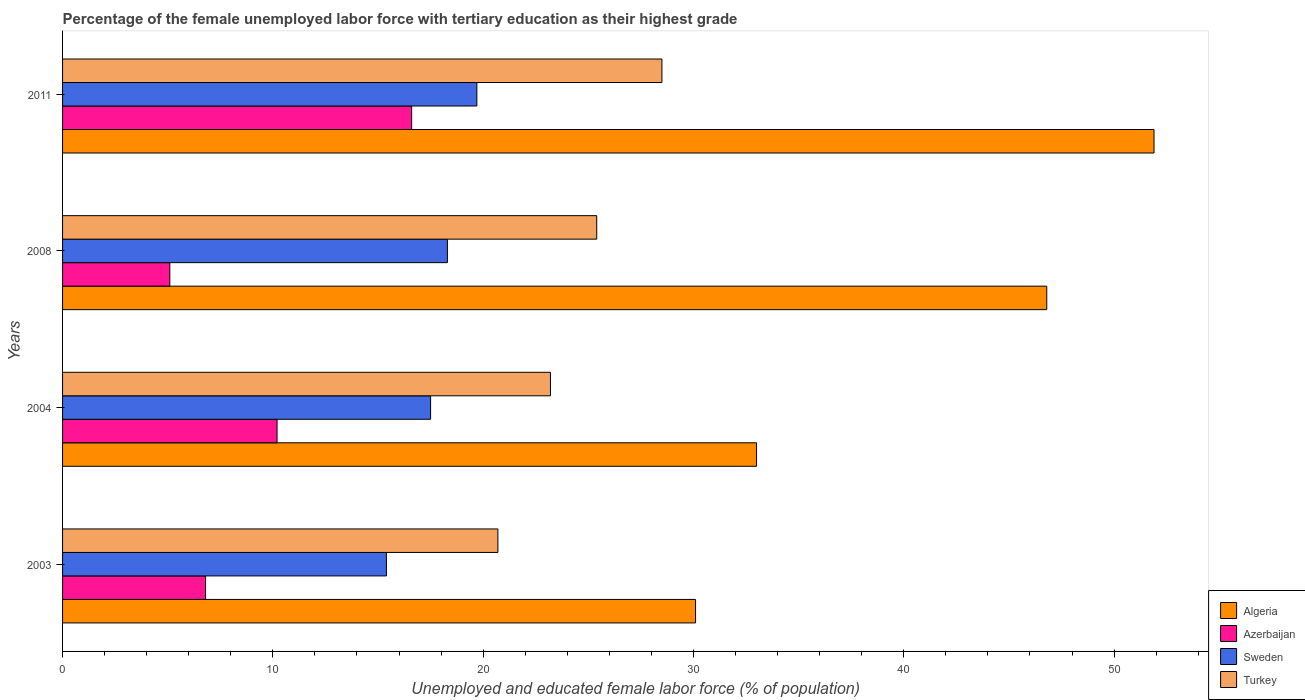How many different coloured bars are there?
Give a very brief answer. 4. How many groups of bars are there?
Your response must be concise. 4. Are the number of bars per tick equal to the number of legend labels?
Offer a very short reply. Yes. Are the number of bars on each tick of the Y-axis equal?
Give a very brief answer. Yes. How many bars are there on the 4th tick from the top?
Keep it short and to the point. 4. How many bars are there on the 3rd tick from the bottom?
Offer a very short reply. 4. What is the percentage of the unemployed female labor force with tertiary education in Sweden in 2008?
Give a very brief answer. 18.3. Across all years, what is the minimum percentage of the unemployed female labor force with tertiary education in Algeria?
Your answer should be compact. 30.1. What is the total percentage of the unemployed female labor force with tertiary education in Sweden in the graph?
Make the answer very short. 70.9. What is the difference between the percentage of the unemployed female labor force with tertiary education in Sweden in 2008 and that in 2011?
Your answer should be compact. -1.4. What is the difference between the percentage of the unemployed female labor force with tertiary education in Turkey in 2011 and the percentage of the unemployed female labor force with tertiary education in Azerbaijan in 2003?
Your answer should be compact. 21.7. What is the average percentage of the unemployed female labor force with tertiary education in Algeria per year?
Your response must be concise. 40.45. In the year 2004, what is the difference between the percentage of the unemployed female labor force with tertiary education in Azerbaijan and percentage of the unemployed female labor force with tertiary education in Algeria?
Your response must be concise. -22.8. What is the ratio of the percentage of the unemployed female labor force with tertiary education in Sweden in 2008 to that in 2011?
Your response must be concise. 0.93. Is the percentage of the unemployed female labor force with tertiary education in Sweden in 2004 less than that in 2011?
Provide a succinct answer. Yes. Is the difference between the percentage of the unemployed female labor force with tertiary education in Azerbaijan in 2008 and 2011 greater than the difference between the percentage of the unemployed female labor force with tertiary education in Algeria in 2008 and 2011?
Your answer should be compact. No. What is the difference between the highest and the second highest percentage of the unemployed female labor force with tertiary education in Turkey?
Your answer should be very brief. 3.1. What is the difference between the highest and the lowest percentage of the unemployed female labor force with tertiary education in Sweden?
Provide a short and direct response. 4.3. In how many years, is the percentage of the unemployed female labor force with tertiary education in Azerbaijan greater than the average percentage of the unemployed female labor force with tertiary education in Azerbaijan taken over all years?
Give a very brief answer. 2. Is the sum of the percentage of the unemployed female labor force with tertiary education in Turkey in 2004 and 2008 greater than the maximum percentage of the unemployed female labor force with tertiary education in Sweden across all years?
Give a very brief answer. Yes. Is it the case that in every year, the sum of the percentage of the unemployed female labor force with tertiary education in Azerbaijan and percentage of the unemployed female labor force with tertiary education in Sweden is greater than the sum of percentage of the unemployed female labor force with tertiary education in Turkey and percentage of the unemployed female labor force with tertiary education in Algeria?
Provide a succinct answer. No. What does the 1st bar from the bottom in 2004 represents?
Make the answer very short. Algeria. Is it the case that in every year, the sum of the percentage of the unemployed female labor force with tertiary education in Turkey and percentage of the unemployed female labor force with tertiary education in Azerbaijan is greater than the percentage of the unemployed female labor force with tertiary education in Algeria?
Your answer should be compact. No. How many years are there in the graph?
Offer a very short reply. 4. What is the difference between two consecutive major ticks on the X-axis?
Offer a very short reply. 10. Are the values on the major ticks of X-axis written in scientific E-notation?
Your answer should be compact. No. How are the legend labels stacked?
Offer a very short reply. Vertical. What is the title of the graph?
Offer a terse response. Percentage of the female unemployed labor force with tertiary education as their highest grade. Does "Senegal" appear as one of the legend labels in the graph?
Provide a short and direct response. No. What is the label or title of the X-axis?
Provide a succinct answer. Unemployed and educated female labor force (% of population). What is the Unemployed and educated female labor force (% of population) in Algeria in 2003?
Your response must be concise. 30.1. What is the Unemployed and educated female labor force (% of population) in Azerbaijan in 2003?
Provide a short and direct response. 6.8. What is the Unemployed and educated female labor force (% of population) in Sweden in 2003?
Keep it short and to the point. 15.4. What is the Unemployed and educated female labor force (% of population) of Turkey in 2003?
Make the answer very short. 20.7. What is the Unemployed and educated female labor force (% of population) in Azerbaijan in 2004?
Offer a terse response. 10.2. What is the Unemployed and educated female labor force (% of population) of Sweden in 2004?
Offer a very short reply. 17.5. What is the Unemployed and educated female labor force (% of population) in Turkey in 2004?
Keep it short and to the point. 23.2. What is the Unemployed and educated female labor force (% of population) of Algeria in 2008?
Offer a terse response. 46.8. What is the Unemployed and educated female labor force (% of population) of Azerbaijan in 2008?
Offer a very short reply. 5.1. What is the Unemployed and educated female labor force (% of population) in Sweden in 2008?
Offer a very short reply. 18.3. What is the Unemployed and educated female labor force (% of population) in Turkey in 2008?
Offer a very short reply. 25.4. What is the Unemployed and educated female labor force (% of population) of Algeria in 2011?
Your response must be concise. 51.9. What is the Unemployed and educated female labor force (% of population) in Azerbaijan in 2011?
Your answer should be very brief. 16.6. What is the Unemployed and educated female labor force (% of population) of Sweden in 2011?
Offer a terse response. 19.7. Across all years, what is the maximum Unemployed and educated female labor force (% of population) of Algeria?
Your answer should be compact. 51.9. Across all years, what is the maximum Unemployed and educated female labor force (% of population) in Azerbaijan?
Your response must be concise. 16.6. Across all years, what is the maximum Unemployed and educated female labor force (% of population) of Sweden?
Provide a succinct answer. 19.7. Across all years, what is the minimum Unemployed and educated female labor force (% of population) in Algeria?
Your answer should be very brief. 30.1. Across all years, what is the minimum Unemployed and educated female labor force (% of population) of Azerbaijan?
Offer a very short reply. 5.1. Across all years, what is the minimum Unemployed and educated female labor force (% of population) in Sweden?
Your answer should be very brief. 15.4. Across all years, what is the minimum Unemployed and educated female labor force (% of population) of Turkey?
Offer a terse response. 20.7. What is the total Unemployed and educated female labor force (% of population) in Algeria in the graph?
Give a very brief answer. 161.8. What is the total Unemployed and educated female labor force (% of population) in Azerbaijan in the graph?
Keep it short and to the point. 38.7. What is the total Unemployed and educated female labor force (% of population) of Sweden in the graph?
Give a very brief answer. 70.9. What is the total Unemployed and educated female labor force (% of population) in Turkey in the graph?
Your answer should be very brief. 97.8. What is the difference between the Unemployed and educated female labor force (% of population) in Algeria in 2003 and that in 2004?
Your answer should be very brief. -2.9. What is the difference between the Unemployed and educated female labor force (% of population) of Azerbaijan in 2003 and that in 2004?
Your answer should be compact. -3.4. What is the difference between the Unemployed and educated female labor force (% of population) in Turkey in 2003 and that in 2004?
Ensure brevity in your answer.  -2.5. What is the difference between the Unemployed and educated female labor force (% of population) in Algeria in 2003 and that in 2008?
Keep it short and to the point. -16.7. What is the difference between the Unemployed and educated female labor force (% of population) of Sweden in 2003 and that in 2008?
Offer a very short reply. -2.9. What is the difference between the Unemployed and educated female labor force (% of population) in Turkey in 2003 and that in 2008?
Give a very brief answer. -4.7. What is the difference between the Unemployed and educated female labor force (% of population) of Algeria in 2003 and that in 2011?
Your answer should be very brief. -21.8. What is the difference between the Unemployed and educated female labor force (% of population) of Azerbaijan in 2003 and that in 2011?
Offer a terse response. -9.8. What is the difference between the Unemployed and educated female labor force (% of population) in Sweden in 2003 and that in 2011?
Make the answer very short. -4.3. What is the difference between the Unemployed and educated female labor force (% of population) in Azerbaijan in 2004 and that in 2008?
Your answer should be compact. 5.1. What is the difference between the Unemployed and educated female labor force (% of population) in Sweden in 2004 and that in 2008?
Make the answer very short. -0.8. What is the difference between the Unemployed and educated female labor force (% of population) of Algeria in 2004 and that in 2011?
Make the answer very short. -18.9. What is the difference between the Unemployed and educated female labor force (% of population) in Turkey in 2004 and that in 2011?
Offer a terse response. -5.3. What is the difference between the Unemployed and educated female labor force (% of population) in Algeria in 2008 and that in 2011?
Your answer should be very brief. -5.1. What is the difference between the Unemployed and educated female labor force (% of population) of Azerbaijan in 2008 and that in 2011?
Offer a terse response. -11.5. What is the difference between the Unemployed and educated female labor force (% of population) in Sweden in 2008 and that in 2011?
Your response must be concise. -1.4. What is the difference between the Unemployed and educated female labor force (% of population) of Turkey in 2008 and that in 2011?
Your answer should be very brief. -3.1. What is the difference between the Unemployed and educated female labor force (% of population) in Algeria in 2003 and the Unemployed and educated female labor force (% of population) in Azerbaijan in 2004?
Provide a succinct answer. 19.9. What is the difference between the Unemployed and educated female labor force (% of population) in Azerbaijan in 2003 and the Unemployed and educated female labor force (% of population) in Turkey in 2004?
Provide a succinct answer. -16.4. What is the difference between the Unemployed and educated female labor force (% of population) of Algeria in 2003 and the Unemployed and educated female labor force (% of population) of Azerbaijan in 2008?
Your response must be concise. 25. What is the difference between the Unemployed and educated female labor force (% of population) of Algeria in 2003 and the Unemployed and educated female labor force (% of population) of Sweden in 2008?
Ensure brevity in your answer.  11.8. What is the difference between the Unemployed and educated female labor force (% of population) of Algeria in 2003 and the Unemployed and educated female labor force (% of population) of Turkey in 2008?
Ensure brevity in your answer.  4.7. What is the difference between the Unemployed and educated female labor force (% of population) in Azerbaijan in 2003 and the Unemployed and educated female labor force (% of population) in Turkey in 2008?
Provide a short and direct response. -18.6. What is the difference between the Unemployed and educated female labor force (% of population) of Algeria in 2003 and the Unemployed and educated female labor force (% of population) of Azerbaijan in 2011?
Make the answer very short. 13.5. What is the difference between the Unemployed and educated female labor force (% of population) of Algeria in 2003 and the Unemployed and educated female labor force (% of population) of Sweden in 2011?
Provide a short and direct response. 10.4. What is the difference between the Unemployed and educated female labor force (% of population) of Algeria in 2003 and the Unemployed and educated female labor force (% of population) of Turkey in 2011?
Offer a terse response. 1.6. What is the difference between the Unemployed and educated female labor force (% of population) in Azerbaijan in 2003 and the Unemployed and educated female labor force (% of population) in Sweden in 2011?
Offer a terse response. -12.9. What is the difference between the Unemployed and educated female labor force (% of population) in Azerbaijan in 2003 and the Unemployed and educated female labor force (% of population) in Turkey in 2011?
Offer a terse response. -21.7. What is the difference between the Unemployed and educated female labor force (% of population) of Sweden in 2003 and the Unemployed and educated female labor force (% of population) of Turkey in 2011?
Offer a terse response. -13.1. What is the difference between the Unemployed and educated female labor force (% of population) of Algeria in 2004 and the Unemployed and educated female labor force (% of population) of Azerbaijan in 2008?
Your response must be concise. 27.9. What is the difference between the Unemployed and educated female labor force (% of population) in Algeria in 2004 and the Unemployed and educated female labor force (% of population) in Sweden in 2008?
Offer a terse response. 14.7. What is the difference between the Unemployed and educated female labor force (% of population) of Azerbaijan in 2004 and the Unemployed and educated female labor force (% of population) of Turkey in 2008?
Your answer should be compact. -15.2. What is the difference between the Unemployed and educated female labor force (% of population) of Algeria in 2004 and the Unemployed and educated female labor force (% of population) of Azerbaijan in 2011?
Offer a very short reply. 16.4. What is the difference between the Unemployed and educated female labor force (% of population) of Algeria in 2004 and the Unemployed and educated female labor force (% of population) of Turkey in 2011?
Make the answer very short. 4.5. What is the difference between the Unemployed and educated female labor force (% of population) in Azerbaijan in 2004 and the Unemployed and educated female labor force (% of population) in Sweden in 2011?
Ensure brevity in your answer.  -9.5. What is the difference between the Unemployed and educated female labor force (% of population) of Azerbaijan in 2004 and the Unemployed and educated female labor force (% of population) of Turkey in 2011?
Make the answer very short. -18.3. What is the difference between the Unemployed and educated female labor force (% of population) in Sweden in 2004 and the Unemployed and educated female labor force (% of population) in Turkey in 2011?
Provide a short and direct response. -11. What is the difference between the Unemployed and educated female labor force (% of population) in Algeria in 2008 and the Unemployed and educated female labor force (% of population) in Azerbaijan in 2011?
Your answer should be compact. 30.2. What is the difference between the Unemployed and educated female labor force (% of population) of Algeria in 2008 and the Unemployed and educated female labor force (% of population) of Sweden in 2011?
Your answer should be very brief. 27.1. What is the difference between the Unemployed and educated female labor force (% of population) of Algeria in 2008 and the Unemployed and educated female labor force (% of population) of Turkey in 2011?
Keep it short and to the point. 18.3. What is the difference between the Unemployed and educated female labor force (% of population) in Azerbaijan in 2008 and the Unemployed and educated female labor force (% of population) in Sweden in 2011?
Your response must be concise. -14.6. What is the difference between the Unemployed and educated female labor force (% of population) in Azerbaijan in 2008 and the Unemployed and educated female labor force (% of population) in Turkey in 2011?
Offer a terse response. -23.4. What is the difference between the Unemployed and educated female labor force (% of population) of Sweden in 2008 and the Unemployed and educated female labor force (% of population) of Turkey in 2011?
Keep it short and to the point. -10.2. What is the average Unemployed and educated female labor force (% of population) in Algeria per year?
Keep it short and to the point. 40.45. What is the average Unemployed and educated female labor force (% of population) in Azerbaijan per year?
Provide a succinct answer. 9.68. What is the average Unemployed and educated female labor force (% of population) of Sweden per year?
Make the answer very short. 17.73. What is the average Unemployed and educated female labor force (% of population) of Turkey per year?
Keep it short and to the point. 24.45. In the year 2003, what is the difference between the Unemployed and educated female labor force (% of population) of Algeria and Unemployed and educated female labor force (% of population) of Azerbaijan?
Your answer should be very brief. 23.3. In the year 2004, what is the difference between the Unemployed and educated female labor force (% of population) of Algeria and Unemployed and educated female labor force (% of population) of Azerbaijan?
Give a very brief answer. 22.8. In the year 2004, what is the difference between the Unemployed and educated female labor force (% of population) of Algeria and Unemployed and educated female labor force (% of population) of Sweden?
Your answer should be compact. 15.5. In the year 2004, what is the difference between the Unemployed and educated female labor force (% of population) of Algeria and Unemployed and educated female labor force (% of population) of Turkey?
Your answer should be compact. 9.8. In the year 2004, what is the difference between the Unemployed and educated female labor force (% of population) in Azerbaijan and Unemployed and educated female labor force (% of population) in Sweden?
Offer a terse response. -7.3. In the year 2008, what is the difference between the Unemployed and educated female labor force (% of population) in Algeria and Unemployed and educated female labor force (% of population) in Azerbaijan?
Your answer should be very brief. 41.7. In the year 2008, what is the difference between the Unemployed and educated female labor force (% of population) of Algeria and Unemployed and educated female labor force (% of population) of Turkey?
Your answer should be very brief. 21.4. In the year 2008, what is the difference between the Unemployed and educated female labor force (% of population) in Azerbaijan and Unemployed and educated female labor force (% of population) in Sweden?
Ensure brevity in your answer.  -13.2. In the year 2008, what is the difference between the Unemployed and educated female labor force (% of population) in Azerbaijan and Unemployed and educated female labor force (% of population) in Turkey?
Your answer should be very brief. -20.3. In the year 2008, what is the difference between the Unemployed and educated female labor force (% of population) of Sweden and Unemployed and educated female labor force (% of population) of Turkey?
Offer a terse response. -7.1. In the year 2011, what is the difference between the Unemployed and educated female labor force (% of population) of Algeria and Unemployed and educated female labor force (% of population) of Azerbaijan?
Your answer should be compact. 35.3. In the year 2011, what is the difference between the Unemployed and educated female labor force (% of population) of Algeria and Unemployed and educated female labor force (% of population) of Sweden?
Your answer should be compact. 32.2. In the year 2011, what is the difference between the Unemployed and educated female labor force (% of population) of Algeria and Unemployed and educated female labor force (% of population) of Turkey?
Provide a short and direct response. 23.4. In the year 2011, what is the difference between the Unemployed and educated female labor force (% of population) of Azerbaijan and Unemployed and educated female labor force (% of population) of Sweden?
Provide a succinct answer. -3.1. What is the ratio of the Unemployed and educated female labor force (% of population) of Algeria in 2003 to that in 2004?
Your answer should be compact. 0.91. What is the ratio of the Unemployed and educated female labor force (% of population) of Azerbaijan in 2003 to that in 2004?
Ensure brevity in your answer.  0.67. What is the ratio of the Unemployed and educated female labor force (% of population) in Sweden in 2003 to that in 2004?
Your answer should be compact. 0.88. What is the ratio of the Unemployed and educated female labor force (% of population) of Turkey in 2003 to that in 2004?
Offer a very short reply. 0.89. What is the ratio of the Unemployed and educated female labor force (% of population) in Algeria in 2003 to that in 2008?
Ensure brevity in your answer.  0.64. What is the ratio of the Unemployed and educated female labor force (% of population) of Azerbaijan in 2003 to that in 2008?
Your response must be concise. 1.33. What is the ratio of the Unemployed and educated female labor force (% of population) in Sweden in 2003 to that in 2008?
Keep it short and to the point. 0.84. What is the ratio of the Unemployed and educated female labor force (% of population) in Turkey in 2003 to that in 2008?
Ensure brevity in your answer.  0.81. What is the ratio of the Unemployed and educated female labor force (% of population) in Algeria in 2003 to that in 2011?
Your answer should be compact. 0.58. What is the ratio of the Unemployed and educated female labor force (% of population) in Azerbaijan in 2003 to that in 2011?
Offer a very short reply. 0.41. What is the ratio of the Unemployed and educated female labor force (% of population) of Sweden in 2003 to that in 2011?
Give a very brief answer. 0.78. What is the ratio of the Unemployed and educated female labor force (% of population) of Turkey in 2003 to that in 2011?
Offer a very short reply. 0.73. What is the ratio of the Unemployed and educated female labor force (% of population) in Algeria in 2004 to that in 2008?
Keep it short and to the point. 0.71. What is the ratio of the Unemployed and educated female labor force (% of population) of Azerbaijan in 2004 to that in 2008?
Your response must be concise. 2. What is the ratio of the Unemployed and educated female labor force (% of population) of Sweden in 2004 to that in 2008?
Make the answer very short. 0.96. What is the ratio of the Unemployed and educated female labor force (% of population) in Turkey in 2004 to that in 2008?
Keep it short and to the point. 0.91. What is the ratio of the Unemployed and educated female labor force (% of population) in Algeria in 2004 to that in 2011?
Provide a succinct answer. 0.64. What is the ratio of the Unemployed and educated female labor force (% of population) of Azerbaijan in 2004 to that in 2011?
Your answer should be compact. 0.61. What is the ratio of the Unemployed and educated female labor force (% of population) of Sweden in 2004 to that in 2011?
Keep it short and to the point. 0.89. What is the ratio of the Unemployed and educated female labor force (% of population) of Turkey in 2004 to that in 2011?
Make the answer very short. 0.81. What is the ratio of the Unemployed and educated female labor force (% of population) in Algeria in 2008 to that in 2011?
Offer a terse response. 0.9. What is the ratio of the Unemployed and educated female labor force (% of population) of Azerbaijan in 2008 to that in 2011?
Provide a short and direct response. 0.31. What is the ratio of the Unemployed and educated female labor force (% of population) in Sweden in 2008 to that in 2011?
Your answer should be compact. 0.93. What is the ratio of the Unemployed and educated female labor force (% of population) of Turkey in 2008 to that in 2011?
Offer a very short reply. 0.89. What is the difference between the highest and the second highest Unemployed and educated female labor force (% of population) of Algeria?
Make the answer very short. 5.1. What is the difference between the highest and the second highest Unemployed and educated female labor force (% of population) of Azerbaijan?
Your answer should be very brief. 6.4. What is the difference between the highest and the second highest Unemployed and educated female labor force (% of population) in Sweden?
Your response must be concise. 1.4. What is the difference between the highest and the lowest Unemployed and educated female labor force (% of population) of Algeria?
Provide a short and direct response. 21.8. What is the difference between the highest and the lowest Unemployed and educated female labor force (% of population) of Turkey?
Offer a very short reply. 7.8. 